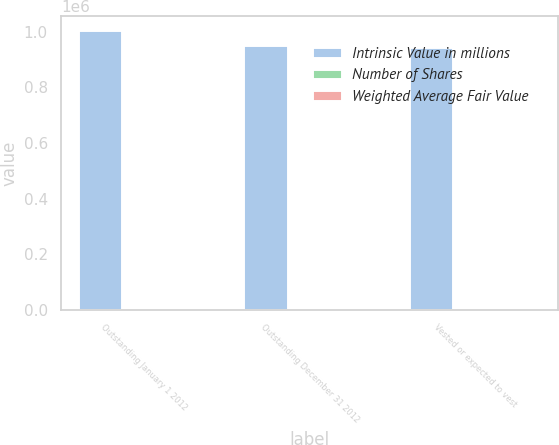Convert chart. <chart><loc_0><loc_0><loc_500><loc_500><stacked_bar_chart><ecel><fcel>Outstanding January 1 2012<fcel>Outstanding December 31 2012<fcel>Vested or expected to vest<nl><fcel>Intrinsic Value in millions<fcel>1.00576e+06<fcel>953936<fcel>945429<nl><fcel>Number of Shares<fcel>46.98<fcel>67.11<fcel>66.97<nl><fcel>Weighted Average Fair Value<fcel>84<fcel>129<fcel>128<nl></chart> 